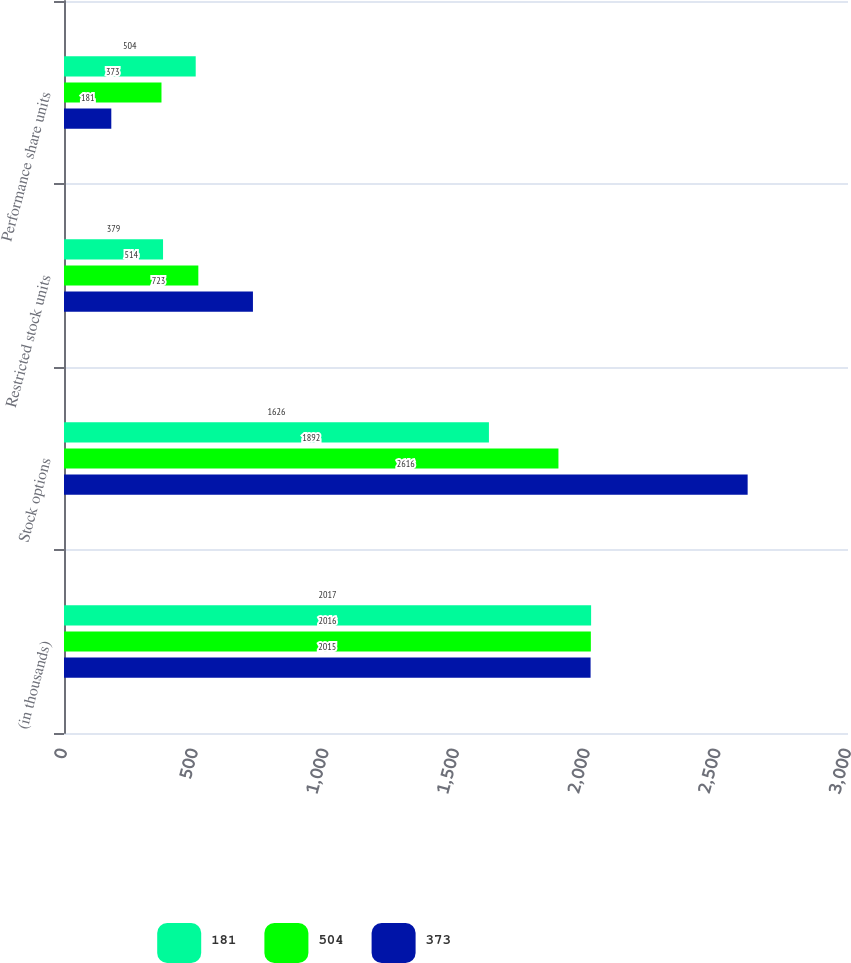<chart> <loc_0><loc_0><loc_500><loc_500><stacked_bar_chart><ecel><fcel>(in thousands)<fcel>Stock options<fcel>Restricted stock units<fcel>Performance share units<nl><fcel>181<fcel>2017<fcel>1626<fcel>379<fcel>504<nl><fcel>504<fcel>2016<fcel>1892<fcel>514<fcel>373<nl><fcel>373<fcel>2015<fcel>2616<fcel>723<fcel>181<nl></chart> 